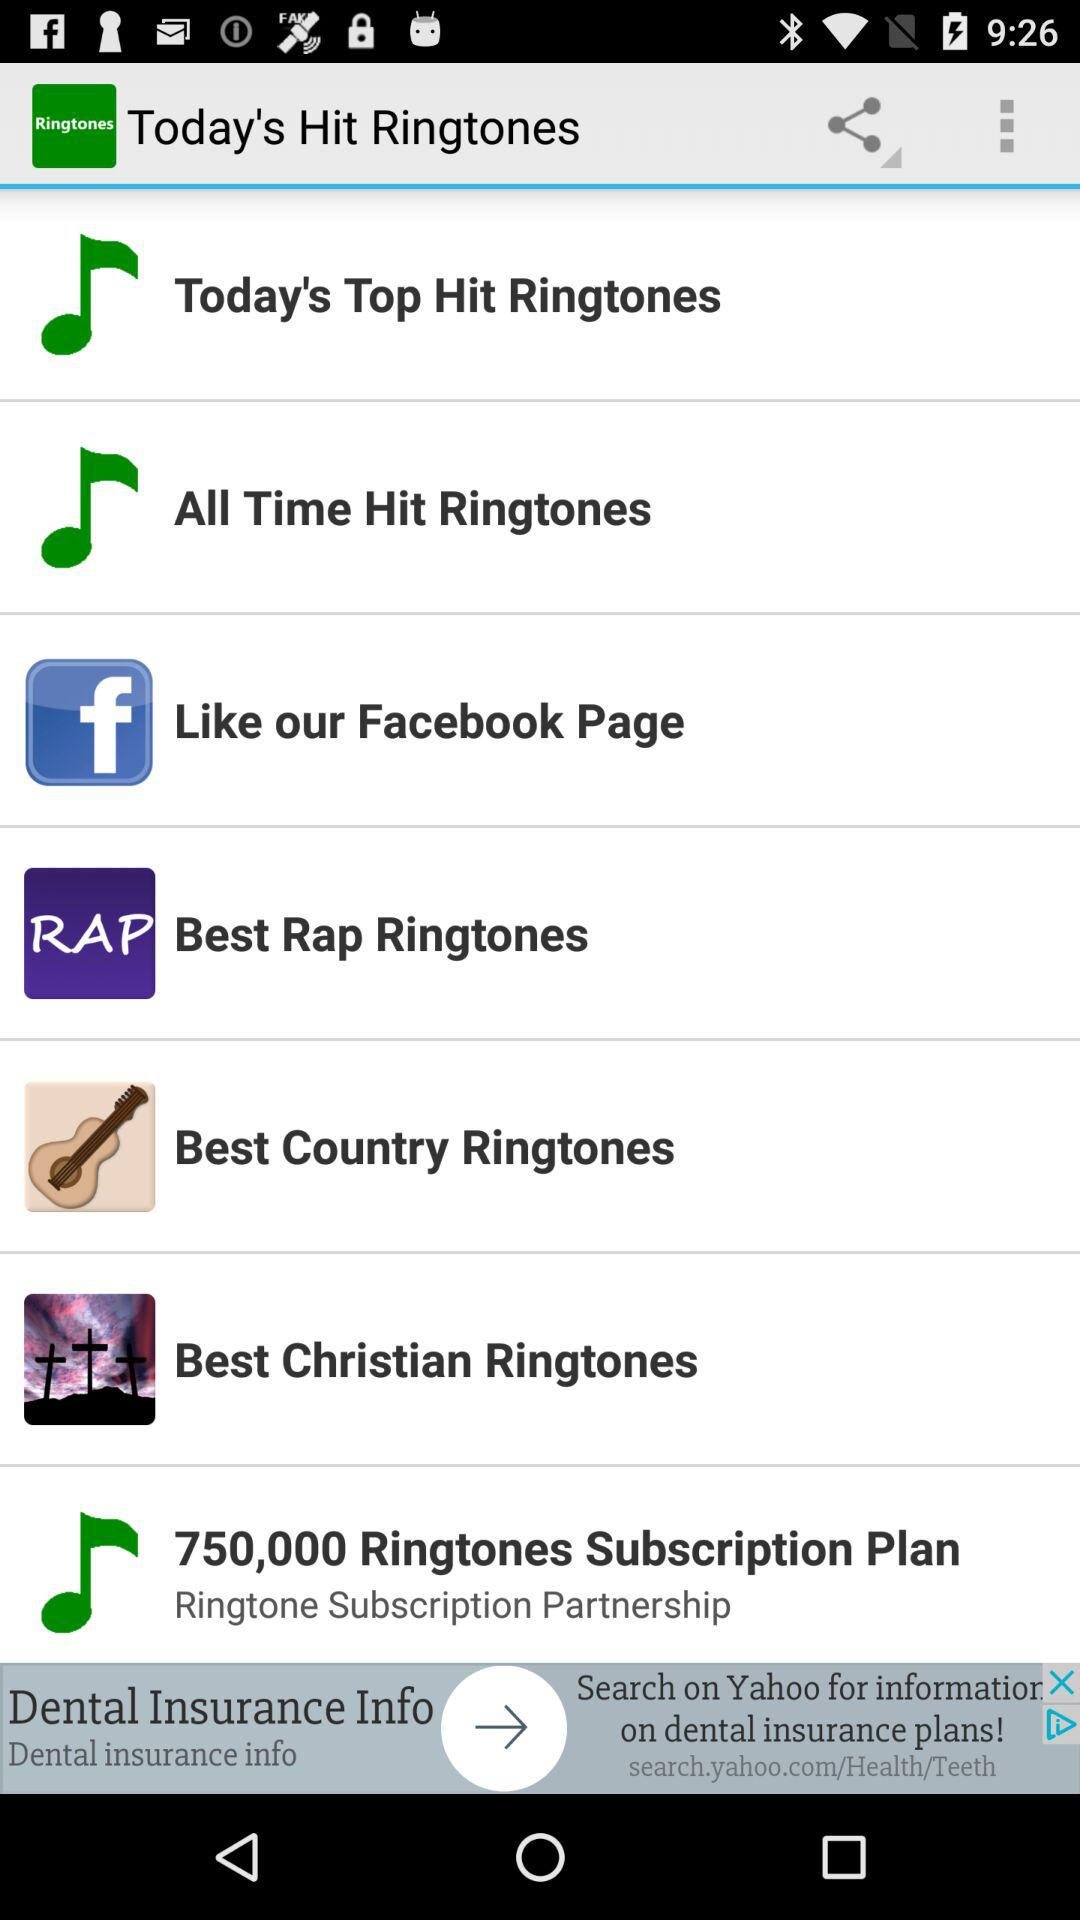What are the different available categories of ringtones? The different available categories of ringtones are "Today's Top Hit Ringtones", "All Time Hit Ringtones", "Best Rap Ringtones", "Best Country Ringtones" and "Best Christian Ringtones". 